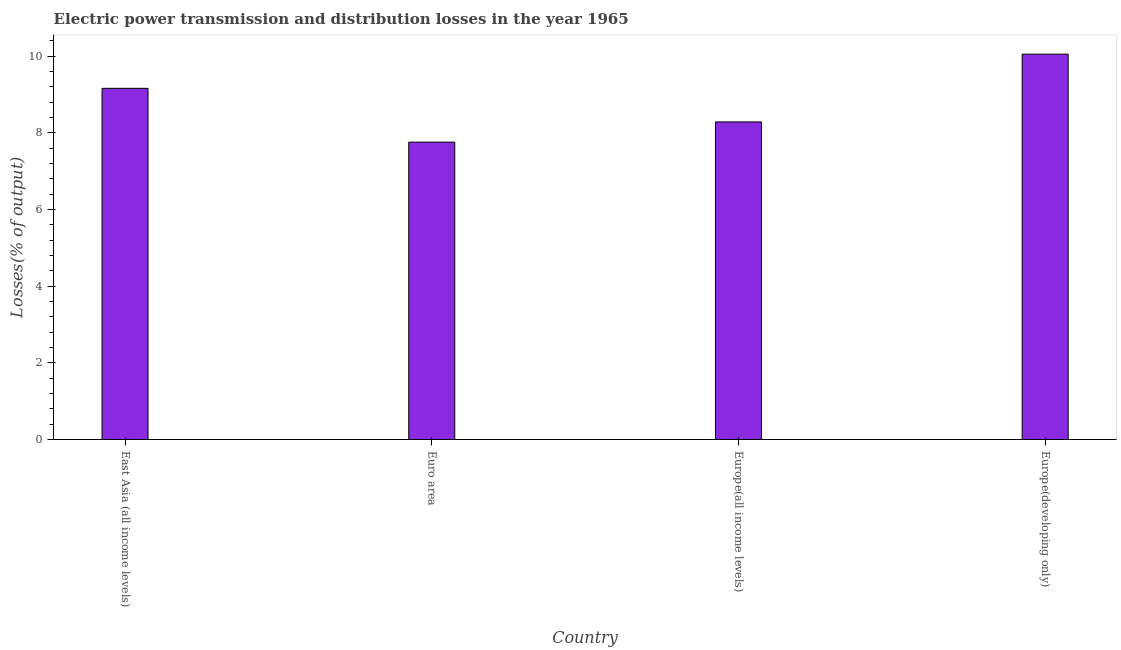Does the graph contain any zero values?
Give a very brief answer. No. What is the title of the graph?
Give a very brief answer. Electric power transmission and distribution losses in the year 1965. What is the label or title of the Y-axis?
Provide a short and direct response. Losses(% of output). What is the electric power transmission and distribution losses in Europe(all income levels)?
Offer a terse response. 8.29. Across all countries, what is the maximum electric power transmission and distribution losses?
Offer a very short reply. 10.05. Across all countries, what is the minimum electric power transmission and distribution losses?
Offer a terse response. 7.76. In which country was the electric power transmission and distribution losses maximum?
Provide a short and direct response. Europe(developing only). What is the sum of the electric power transmission and distribution losses?
Offer a very short reply. 35.26. What is the difference between the electric power transmission and distribution losses in Euro area and Europe(developing only)?
Your response must be concise. -2.29. What is the average electric power transmission and distribution losses per country?
Your response must be concise. 8.81. What is the median electric power transmission and distribution losses?
Offer a terse response. 8.72. In how many countries, is the electric power transmission and distribution losses greater than 5.2 %?
Your response must be concise. 4. What is the ratio of the electric power transmission and distribution losses in East Asia (all income levels) to that in Europe(all income levels)?
Offer a very short reply. 1.11. Is the difference between the electric power transmission and distribution losses in East Asia (all income levels) and Europe(all income levels) greater than the difference between any two countries?
Your answer should be very brief. No. What is the difference between the highest and the second highest electric power transmission and distribution losses?
Provide a succinct answer. 0.89. Is the sum of the electric power transmission and distribution losses in Europe(all income levels) and Europe(developing only) greater than the maximum electric power transmission and distribution losses across all countries?
Your answer should be very brief. Yes. What is the difference between the highest and the lowest electric power transmission and distribution losses?
Provide a succinct answer. 2.3. How many countries are there in the graph?
Your answer should be very brief. 4. What is the difference between two consecutive major ticks on the Y-axis?
Make the answer very short. 2. What is the Losses(% of output) in East Asia (all income levels)?
Your answer should be compact. 9.16. What is the Losses(% of output) of Euro area?
Make the answer very short. 7.76. What is the Losses(% of output) in Europe(all income levels)?
Your answer should be very brief. 8.29. What is the Losses(% of output) of Europe(developing only)?
Your answer should be very brief. 10.05. What is the difference between the Losses(% of output) in East Asia (all income levels) and Euro area?
Your answer should be compact. 1.4. What is the difference between the Losses(% of output) in East Asia (all income levels) and Europe(all income levels)?
Provide a succinct answer. 0.88. What is the difference between the Losses(% of output) in East Asia (all income levels) and Europe(developing only)?
Make the answer very short. -0.89. What is the difference between the Losses(% of output) in Euro area and Europe(all income levels)?
Make the answer very short. -0.53. What is the difference between the Losses(% of output) in Euro area and Europe(developing only)?
Provide a short and direct response. -2.3. What is the difference between the Losses(% of output) in Europe(all income levels) and Europe(developing only)?
Your answer should be compact. -1.77. What is the ratio of the Losses(% of output) in East Asia (all income levels) to that in Euro area?
Make the answer very short. 1.18. What is the ratio of the Losses(% of output) in East Asia (all income levels) to that in Europe(all income levels)?
Make the answer very short. 1.11. What is the ratio of the Losses(% of output) in East Asia (all income levels) to that in Europe(developing only)?
Offer a terse response. 0.91. What is the ratio of the Losses(% of output) in Euro area to that in Europe(all income levels)?
Offer a terse response. 0.94. What is the ratio of the Losses(% of output) in Euro area to that in Europe(developing only)?
Provide a short and direct response. 0.77. What is the ratio of the Losses(% of output) in Europe(all income levels) to that in Europe(developing only)?
Make the answer very short. 0.82. 